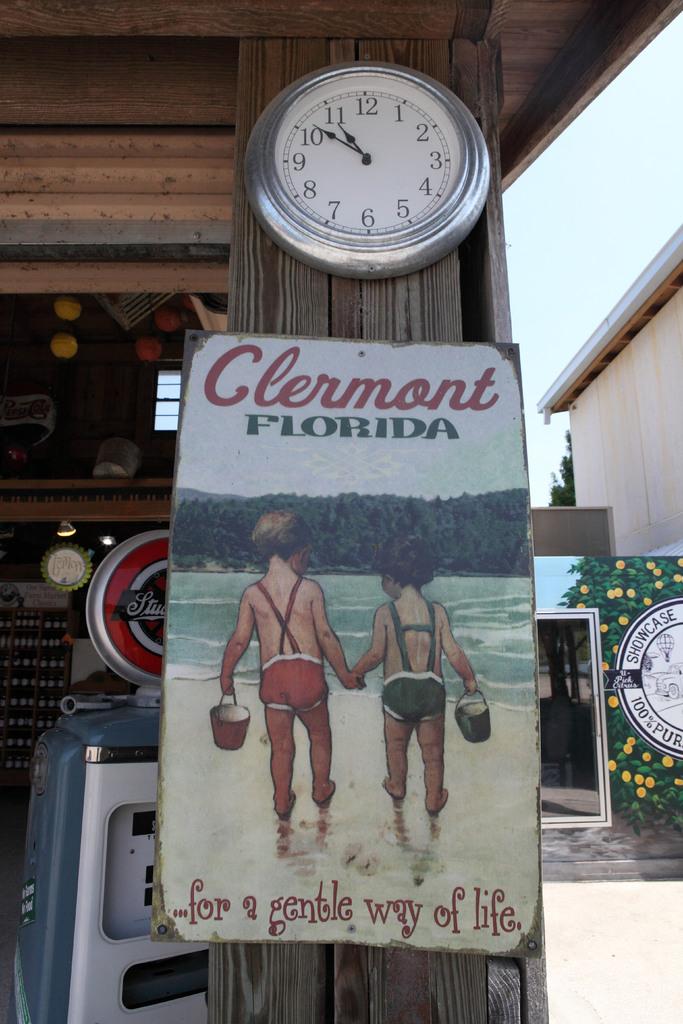What does the quote say on the bottom of the sign?
Provide a succinct answer. For a gentle way of life. 